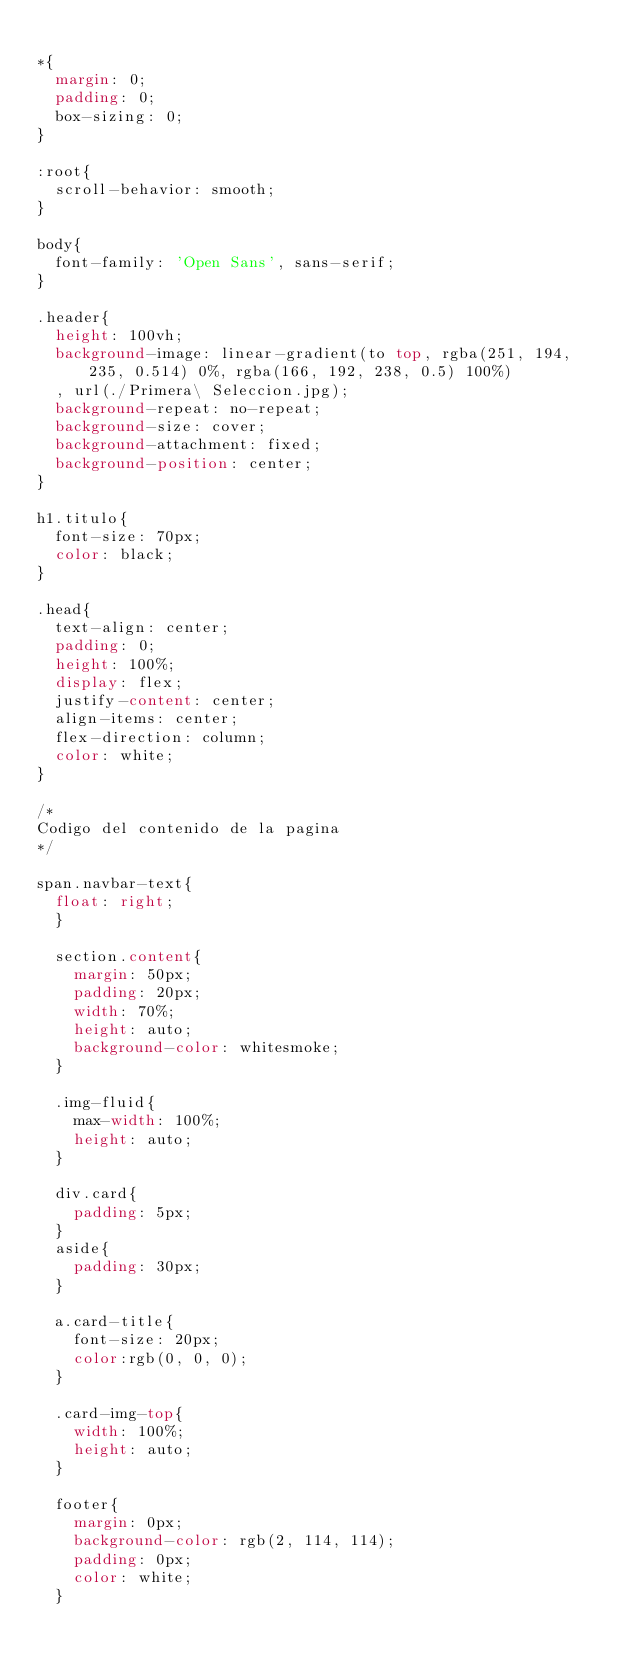Convert code to text. <code><loc_0><loc_0><loc_500><loc_500><_CSS_>
*{
  margin: 0;
  padding: 0;
  box-sizing: 0;
}

:root{
  scroll-behavior: smooth;
}

body{
  font-family: 'Open Sans', sans-serif;    
}

.header{
  height: 100vh;
  background-image: linear-gradient(to top, rgba(251, 194, 235, 0.514) 0%, rgba(166, 192, 238, 0.5) 100%)
  , url(./Primera\ Seleccion.jpg);
  background-repeat: no-repeat;
  background-size: cover;
  background-attachment: fixed;
  background-position: center;
}

h1.titulo{
  font-size: 70px;
  color: black;
}

.head{
  text-align: center;
  padding: 0;
  height: 100%;
  display: flex;
  justify-content: center;
  align-items: center;
  flex-direction: column;
  color: white;
}

/*
Codigo del contenido de la pagina
*/

span.navbar-text{
  float: right;
  }
  
  section.content{
    margin: 50px;
    padding: 20px;
    width: 70%;
    height: auto;
    background-color: whitesmoke;
  }
  
  .img-fluid{
    max-width: 100%; 
    height: auto;
  }
  
  div.card{
    padding: 5px;
  }
  aside{
    padding: 30px;
  }
  
  a.card-title{
    font-size: 20px;
    color:rgb(0, 0, 0);
  }
  
  .card-img-top{
    width: 100%;
    height: auto;
  }
  
  footer{
    margin: 0px;
    background-color: rgb(2, 114, 114);
    padding: 0px;
    color: white;
  }</code> 